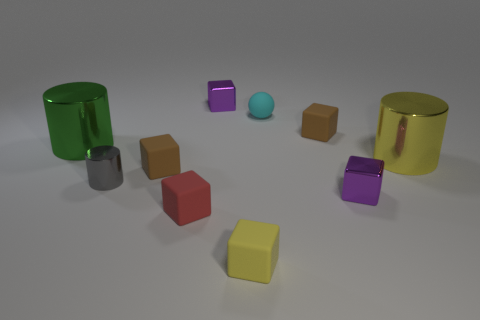What is the size of the green metal object that is the same shape as the yellow metallic thing?
Your answer should be very brief. Large. What number of small things are yellow matte spheres or cyan spheres?
Your answer should be very brief. 1. Is the material of the purple cube to the left of the yellow matte thing the same as the tiny purple cube in front of the green metal thing?
Offer a terse response. Yes. What is the large object that is left of the large yellow metal object made of?
Give a very brief answer. Metal. How many matte objects are either cyan objects or large green objects?
Offer a very short reply. 1. The big cylinder that is to the left of the brown matte block that is in front of the yellow metal cylinder is what color?
Offer a very short reply. Green. Do the red thing and the brown block that is on the right side of the cyan rubber object have the same material?
Keep it short and to the point. Yes. What is the color of the tiny metal object that is behind the metallic cylinder that is on the right side of the small metal cube behind the small gray metal thing?
Provide a succinct answer. Purple. Is there any other thing that has the same shape as the green metallic thing?
Keep it short and to the point. Yes. Is the number of yellow shiny objects greater than the number of small purple blocks?
Ensure brevity in your answer.  No. 